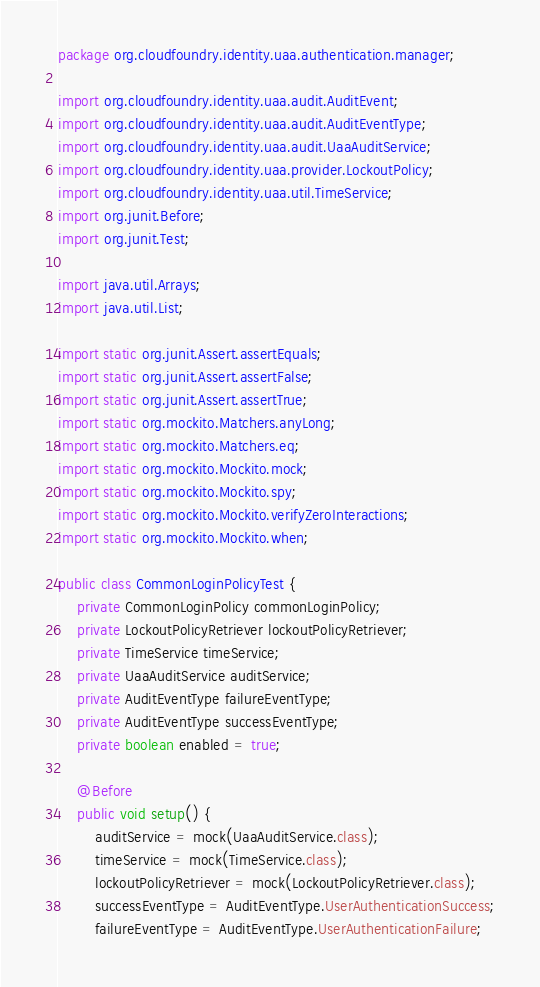<code> <loc_0><loc_0><loc_500><loc_500><_Java_>package org.cloudfoundry.identity.uaa.authentication.manager;

import org.cloudfoundry.identity.uaa.audit.AuditEvent;
import org.cloudfoundry.identity.uaa.audit.AuditEventType;
import org.cloudfoundry.identity.uaa.audit.UaaAuditService;
import org.cloudfoundry.identity.uaa.provider.LockoutPolicy;
import org.cloudfoundry.identity.uaa.util.TimeService;
import org.junit.Before;
import org.junit.Test;

import java.util.Arrays;
import java.util.List;

import static org.junit.Assert.assertEquals;
import static org.junit.Assert.assertFalse;
import static org.junit.Assert.assertTrue;
import static org.mockito.Matchers.anyLong;
import static org.mockito.Matchers.eq;
import static org.mockito.Mockito.mock;
import static org.mockito.Mockito.spy;
import static org.mockito.Mockito.verifyZeroInteractions;
import static org.mockito.Mockito.when;

public class CommonLoginPolicyTest {
    private CommonLoginPolicy commonLoginPolicy;
    private LockoutPolicyRetriever lockoutPolicyRetriever;
    private TimeService timeService;
    private UaaAuditService auditService;
    private AuditEventType failureEventType;
    private AuditEventType successEventType;
    private boolean enabled = true;

    @Before
    public void setup() {
        auditService = mock(UaaAuditService.class);
        timeService = mock(TimeService.class);
        lockoutPolicyRetriever = mock(LockoutPolicyRetriever.class);
        successEventType = AuditEventType.UserAuthenticationSuccess;
        failureEventType = AuditEventType.UserAuthenticationFailure;
</code> 